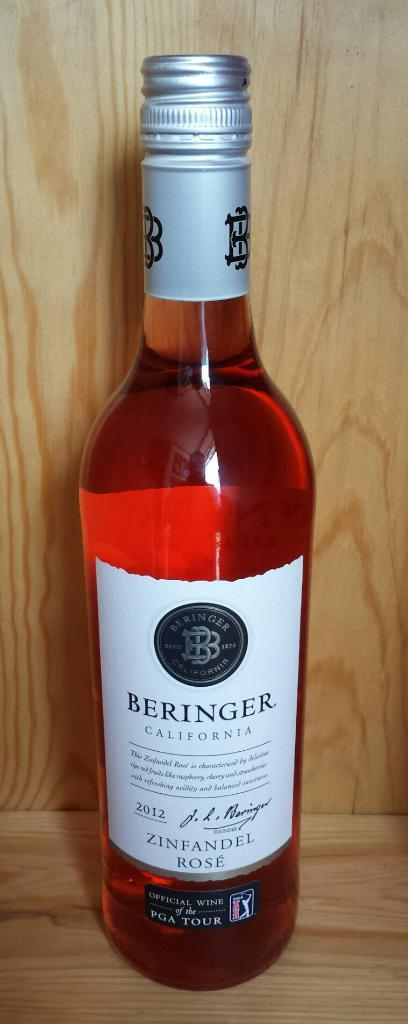<image>
Offer a succinct explanation of the picture presented. A bottle of pink liquid that reads BERINGER CALIFORNIA. 